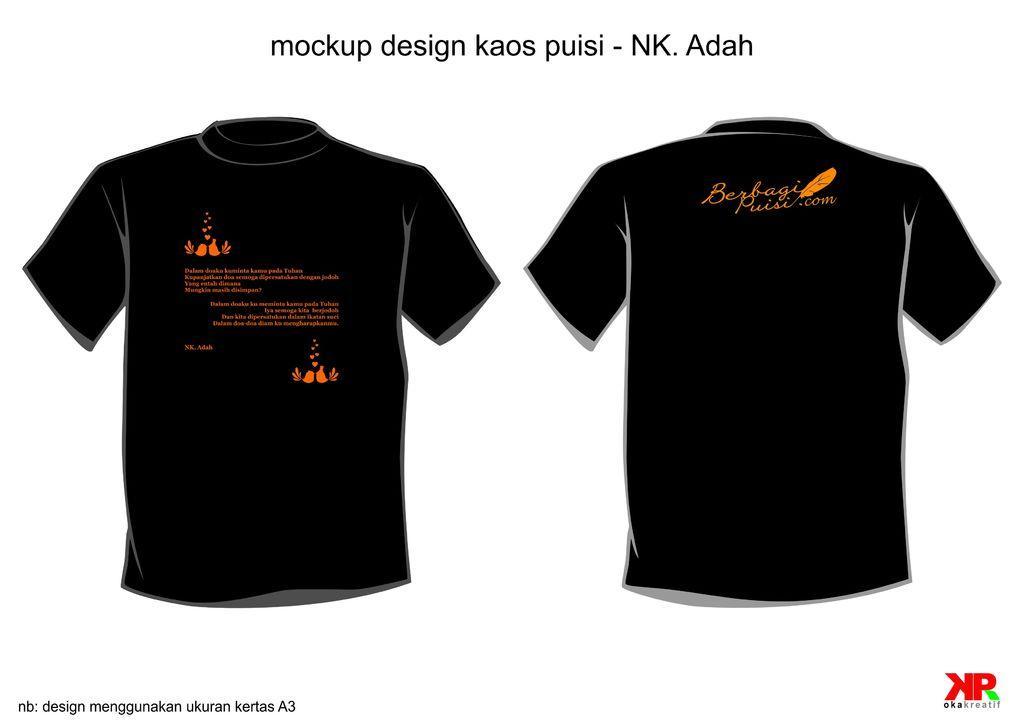How would you summarize this image in a sentence or two? In the image there are two black color t-shirts. On these something is written in orange. 